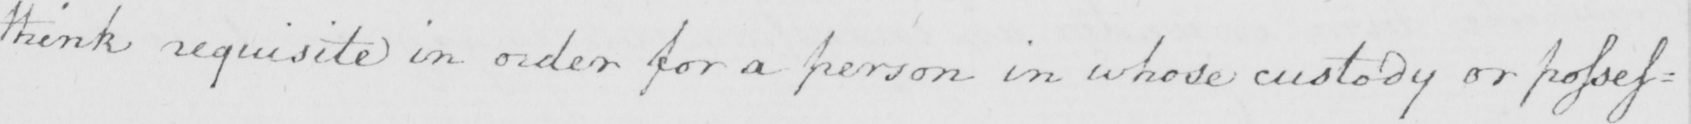Please transcribe the handwritten text in this image. think requisite in order for a person in whose custody or posses : 